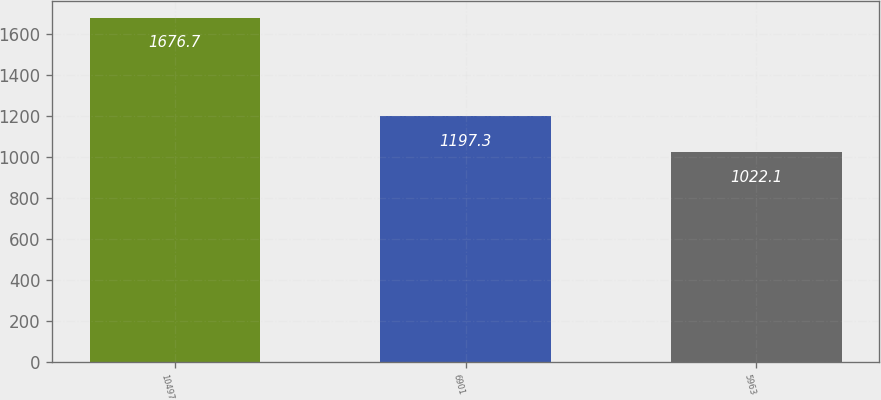<chart> <loc_0><loc_0><loc_500><loc_500><bar_chart><fcel>10497<fcel>6901<fcel>5963<nl><fcel>1676.7<fcel>1197.3<fcel>1022.1<nl></chart> 